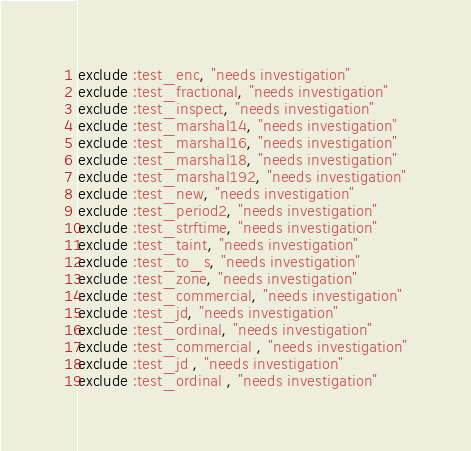Convert code to text. <code><loc_0><loc_0><loc_500><loc_500><_Ruby_>exclude :test_enc, "needs investigation"
exclude :test_fractional, "needs investigation"
exclude :test_inspect, "needs investigation"
exclude :test_marshal14, "needs investigation"
exclude :test_marshal16, "needs investigation"
exclude :test_marshal18, "needs investigation"
exclude :test_marshal192, "needs investigation"
exclude :test_new, "needs investigation"
exclude :test_period2, "needs investigation"
exclude :test_strftime, "needs investigation"
exclude :test_taint, "needs investigation"
exclude :test_to_s, "needs investigation"
exclude :test_zone, "needs investigation"
exclude :test_commercial, "needs investigation"
exclude :test_jd, "needs investigation"
exclude :test_ordinal, "needs investigation"
exclude :test_commercial , "needs investigation"
exclude :test_jd , "needs investigation"
exclude :test_ordinal , "needs investigation"
</code> 